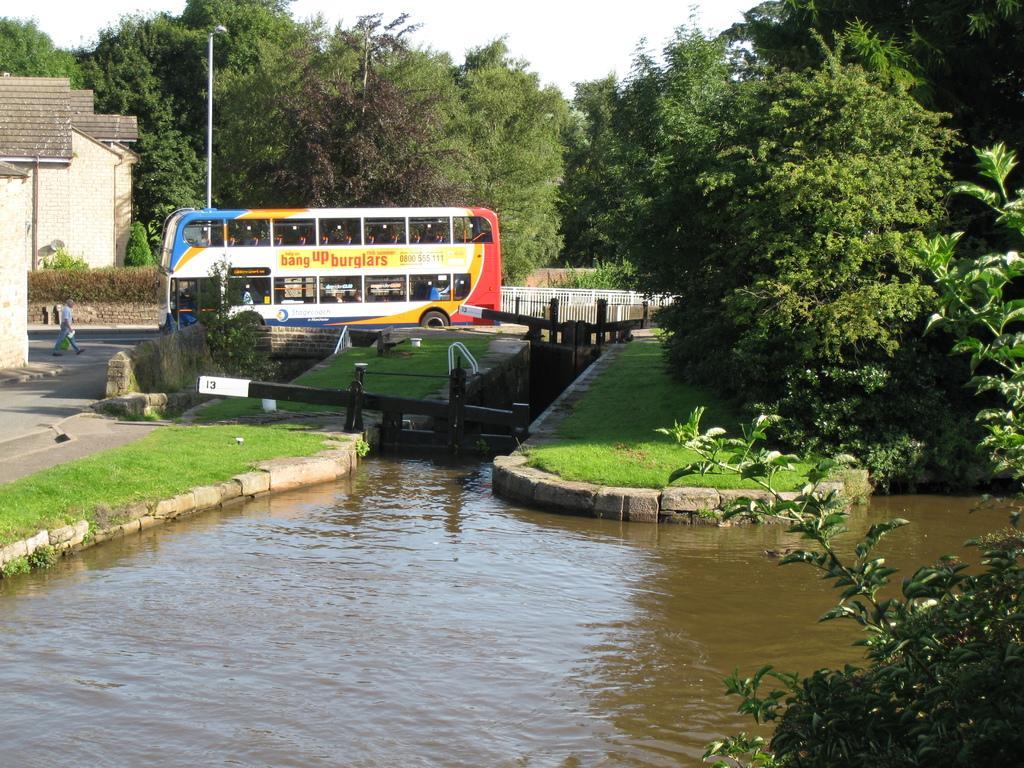In one or two sentences, can you explain what this image depicts? In this picture there is a bus on the road and there is a person walking on the road. On the left side of the image there are buildings. At the back there are trees and there is a pole. At the top there is sky. At the bottom there is water and grass. 